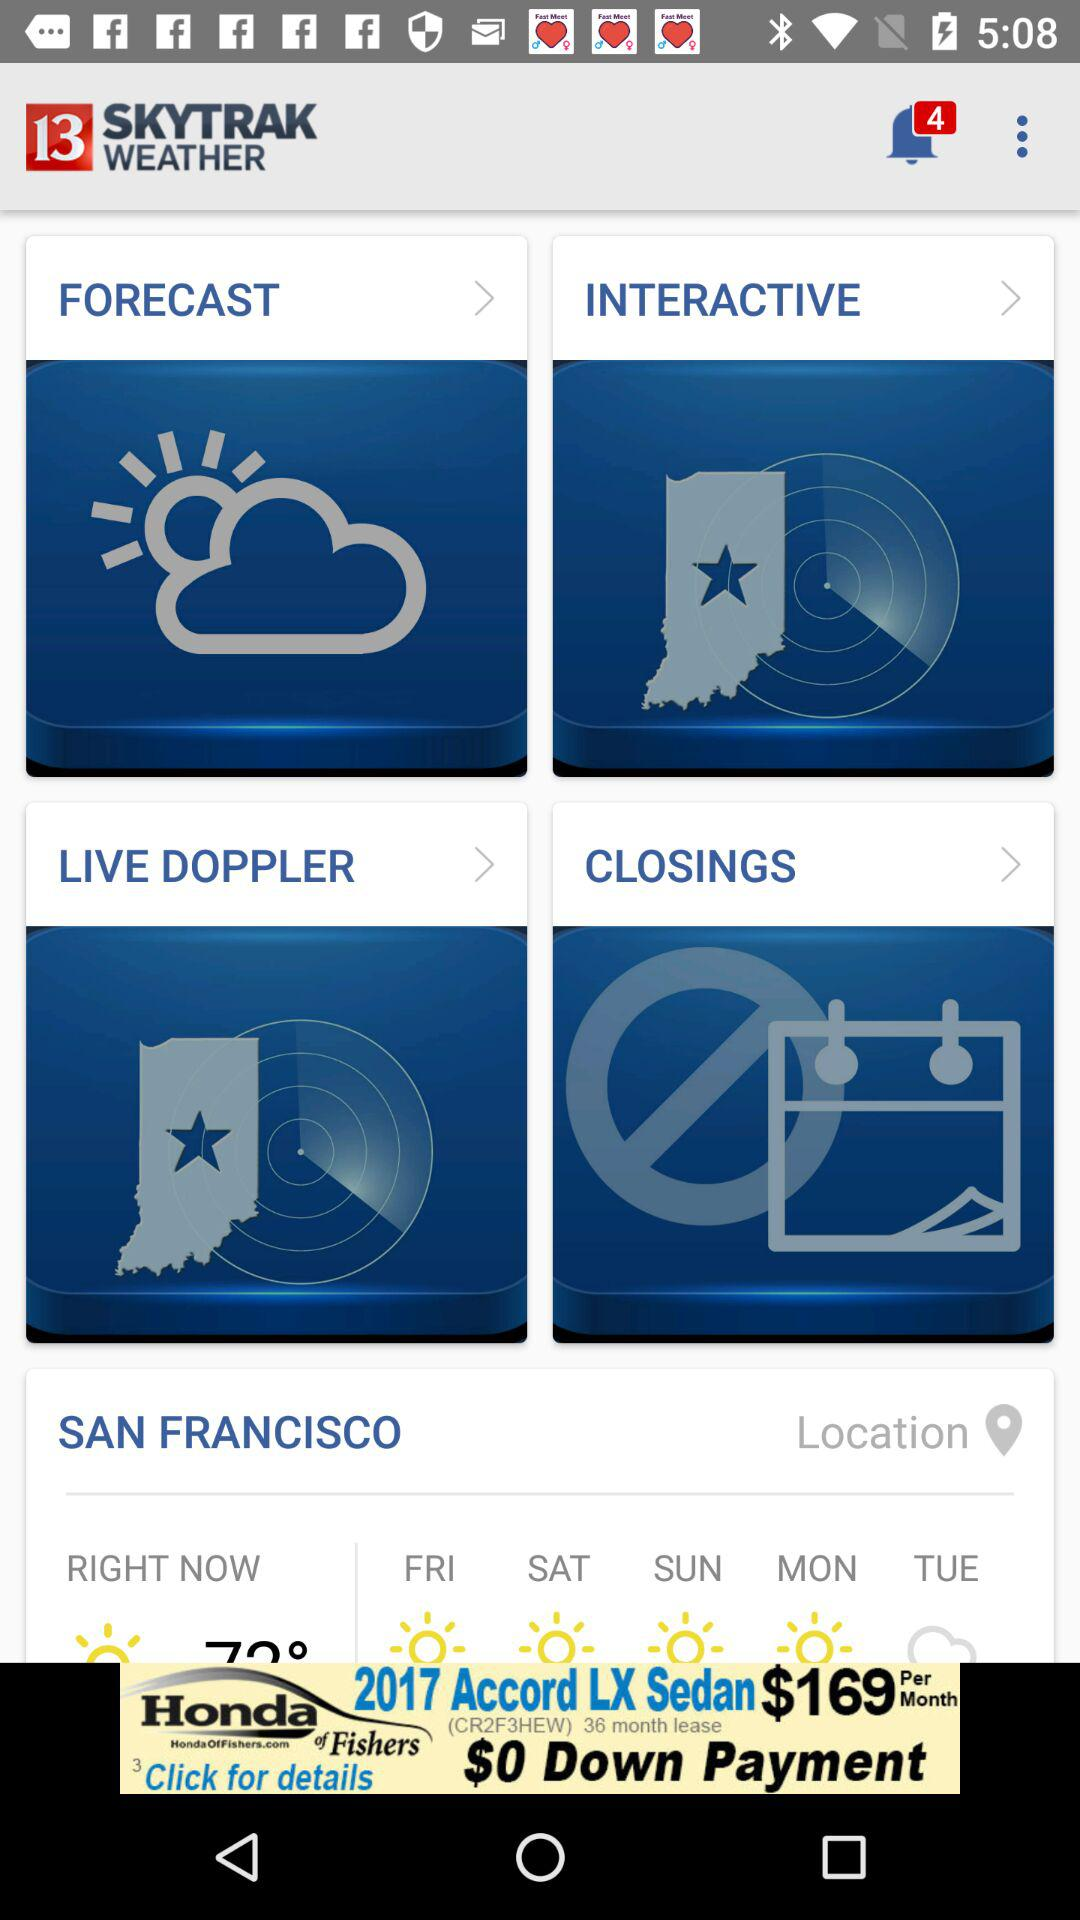What is the name of the application? The name of the application is "13 SKYTRAK WEATHER". 